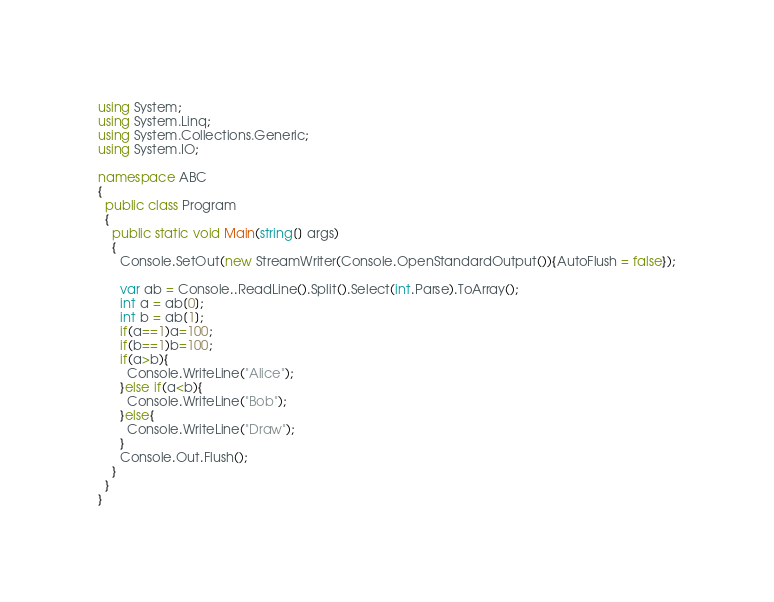<code> <loc_0><loc_0><loc_500><loc_500><_C#_>using System;
using System.Linq;
using System.Collections.Generic;
using System.IO;
 
namespace ABC
{
  public class Program
  {
    public static void Main(string[] args)
    {
      Console.SetOut(new StreamWriter(Console.OpenStandardOutput()){AutoFlush = false});

      var ab = Console..ReadLine().Split().Select(int.Parse).ToArray();
      int a = ab[0];
      int b = ab[1];
      if(a==1)a=100;
      if(b==1)b=100;
      if(a>b){
        Console.WriteLine("Alice");
      }else if(a<b){
        Console.WriteLine("Bob");
      }else{
        Console.WriteLine("Draw");
      }
      Console.Out.Flush();
    }
  }
}</code> 